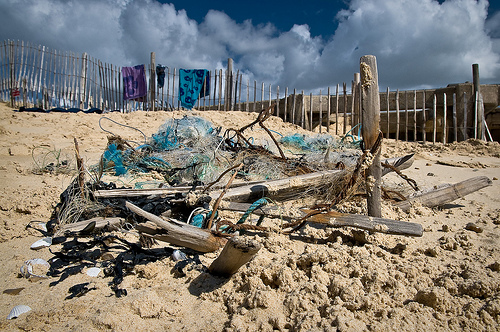<image>
Is there a wood on the sand? Yes. Looking at the image, I can see the wood is positioned on top of the sand, with the sand providing support. Is there a shell on the wood? No. The shell is not positioned on the wood. They may be near each other, but the shell is not supported by or resting on top of the wood. Is there a sky behind the sand? Yes. From this viewpoint, the sky is positioned behind the sand, with the sand partially or fully occluding the sky. 